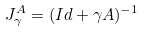<formula> <loc_0><loc_0><loc_500><loc_500>J ^ { A } _ { \gamma } = ( I d + \gamma A ) ^ { - 1 }</formula> 